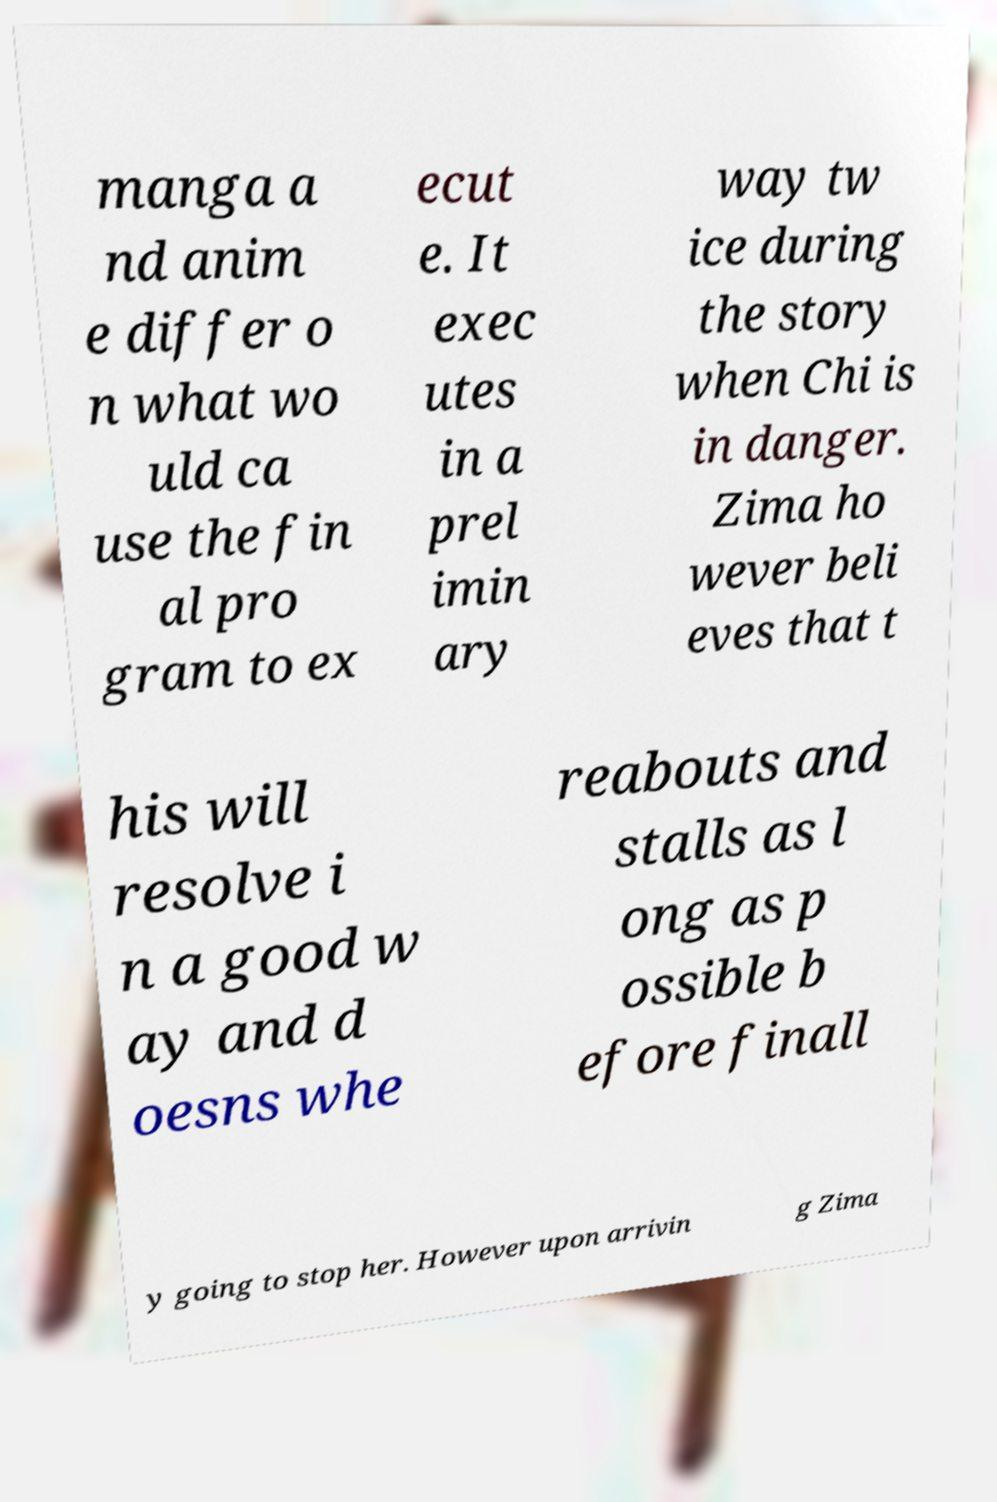Can you accurately transcribe the text from the provided image for me? manga a nd anim e differ o n what wo uld ca use the fin al pro gram to ex ecut e. It exec utes in a prel imin ary way tw ice during the story when Chi is in danger. Zima ho wever beli eves that t his will resolve i n a good w ay and d oesns whe reabouts and stalls as l ong as p ossible b efore finall y going to stop her. However upon arrivin g Zima 